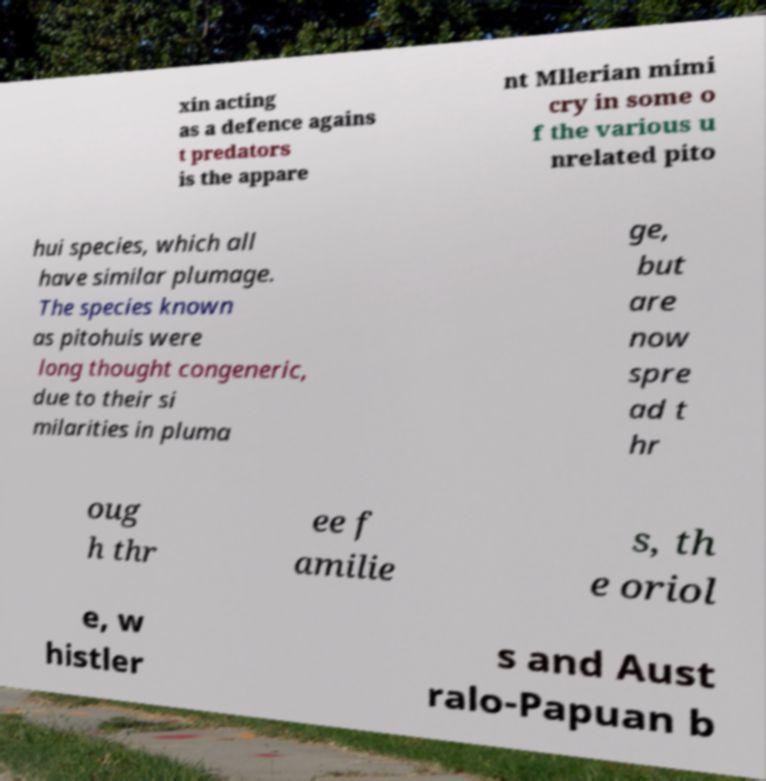For documentation purposes, I need the text within this image transcribed. Could you provide that? xin acting as a defence agains t predators is the appare nt Mllerian mimi cry in some o f the various u nrelated pito hui species, which all have similar plumage. The species known as pitohuis were long thought congeneric, due to their si milarities in pluma ge, but are now spre ad t hr oug h thr ee f amilie s, th e oriol e, w histler s and Aust ralo-Papuan b 